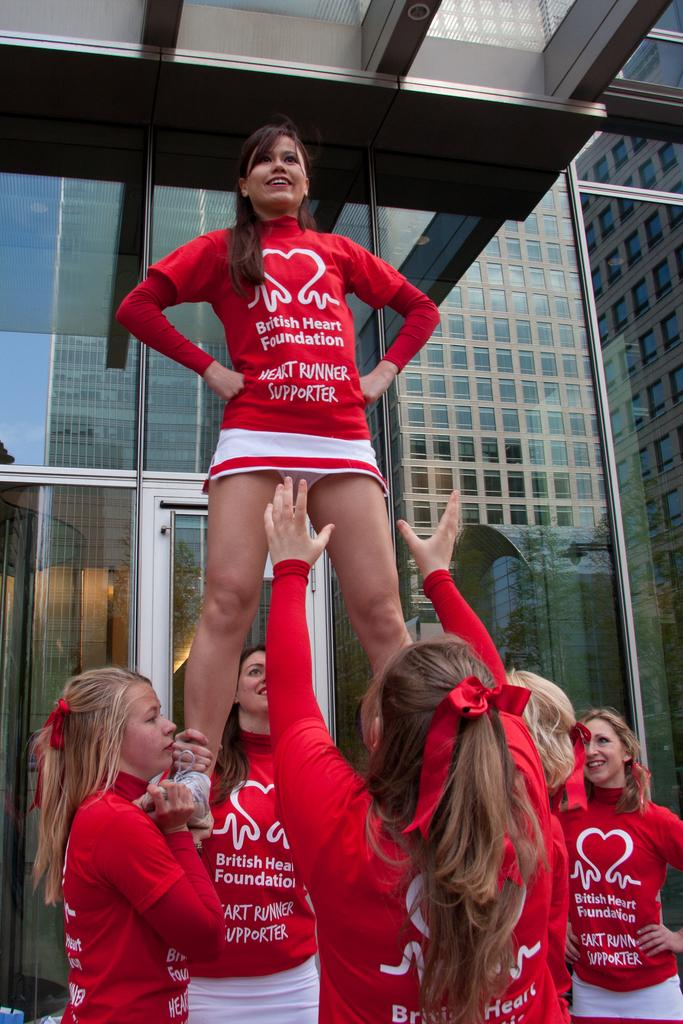Provide a one-sentence caption for the provided image. British Heart Foundation Cheerleaders doing a dangerous stunt. 